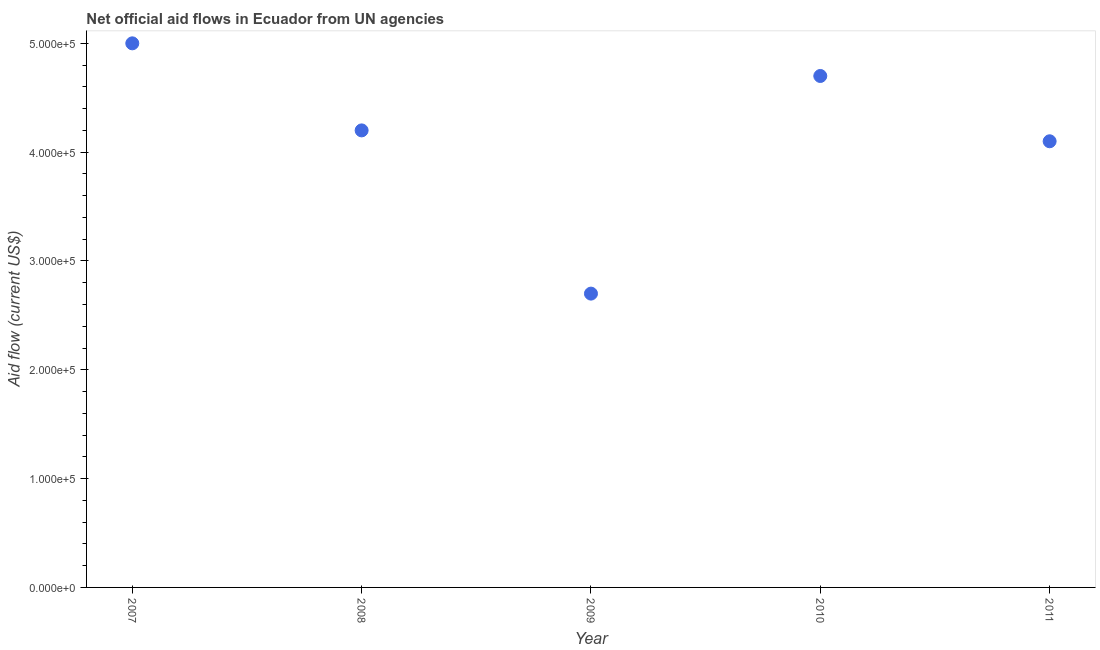What is the net official flows from un agencies in 2011?
Provide a short and direct response. 4.10e+05. Across all years, what is the maximum net official flows from un agencies?
Give a very brief answer. 5.00e+05. Across all years, what is the minimum net official flows from un agencies?
Ensure brevity in your answer.  2.70e+05. What is the sum of the net official flows from un agencies?
Your response must be concise. 2.07e+06. What is the difference between the net official flows from un agencies in 2010 and 2011?
Ensure brevity in your answer.  6.00e+04. What is the average net official flows from un agencies per year?
Provide a short and direct response. 4.14e+05. What is the ratio of the net official flows from un agencies in 2007 to that in 2008?
Ensure brevity in your answer.  1.19. Is the difference between the net official flows from un agencies in 2007 and 2008 greater than the difference between any two years?
Give a very brief answer. No. What is the difference between the highest and the lowest net official flows from un agencies?
Keep it short and to the point. 2.30e+05. In how many years, is the net official flows from un agencies greater than the average net official flows from un agencies taken over all years?
Offer a terse response. 3. How many dotlines are there?
Provide a short and direct response. 1. How many years are there in the graph?
Offer a terse response. 5. What is the difference between two consecutive major ticks on the Y-axis?
Offer a very short reply. 1.00e+05. Are the values on the major ticks of Y-axis written in scientific E-notation?
Keep it short and to the point. Yes. Does the graph contain grids?
Keep it short and to the point. No. What is the title of the graph?
Make the answer very short. Net official aid flows in Ecuador from UN agencies. What is the Aid flow (current US$) in 2009?
Make the answer very short. 2.70e+05. What is the Aid flow (current US$) in 2010?
Offer a very short reply. 4.70e+05. What is the Aid flow (current US$) in 2011?
Make the answer very short. 4.10e+05. What is the difference between the Aid flow (current US$) in 2007 and 2011?
Provide a succinct answer. 9.00e+04. What is the difference between the Aid flow (current US$) in 2008 and 2011?
Your answer should be compact. 10000. What is the difference between the Aid flow (current US$) in 2009 and 2011?
Provide a short and direct response. -1.40e+05. What is the difference between the Aid flow (current US$) in 2010 and 2011?
Make the answer very short. 6.00e+04. What is the ratio of the Aid flow (current US$) in 2007 to that in 2008?
Provide a short and direct response. 1.19. What is the ratio of the Aid flow (current US$) in 2007 to that in 2009?
Your response must be concise. 1.85. What is the ratio of the Aid flow (current US$) in 2007 to that in 2010?
Your response must be concise. 1.06. What is the ratio of the Aid flow (current US$) in 2007 to that in 2011?
Provide a short and direct response. 1.22. What is the ratio of the Aid flow (current US$) in 2008 to that in 2009?
Offer a terse response. 1.56. What is the ratio of the Aid flow (current US$) in 2008 to that in 2010?
Your response must be concise. 0.89. What is the ratio of the Aid flow (current US$) in 2008 to that in 2011?
Ensure brevity in your answer.  1.02. What is the ratio of the Aid flow (current US$) in 2009 to that in 2010?
Your answer should be compact. 0.57. What is the ratio of the Aid flow (current US$) in 2009 to that in 2011?
Offer a terse response. 0.66. What is the ratio of the Aid flow (current US$) in 2010 to that in 2011?
Give a very brief answer. 1.15. 